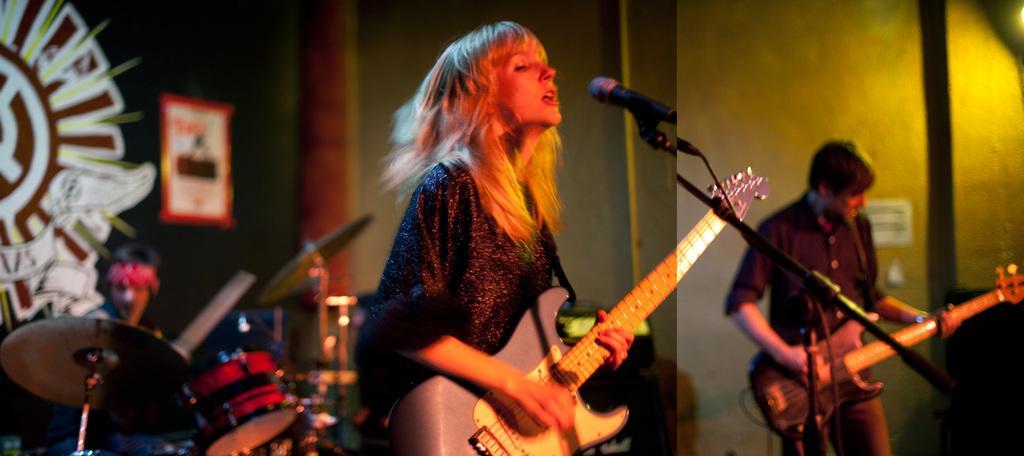Can you describe this image briefly? This picture shows a man and a woman playing guitar and women singing with the help of a microphone and we see a man seated and playing drums 